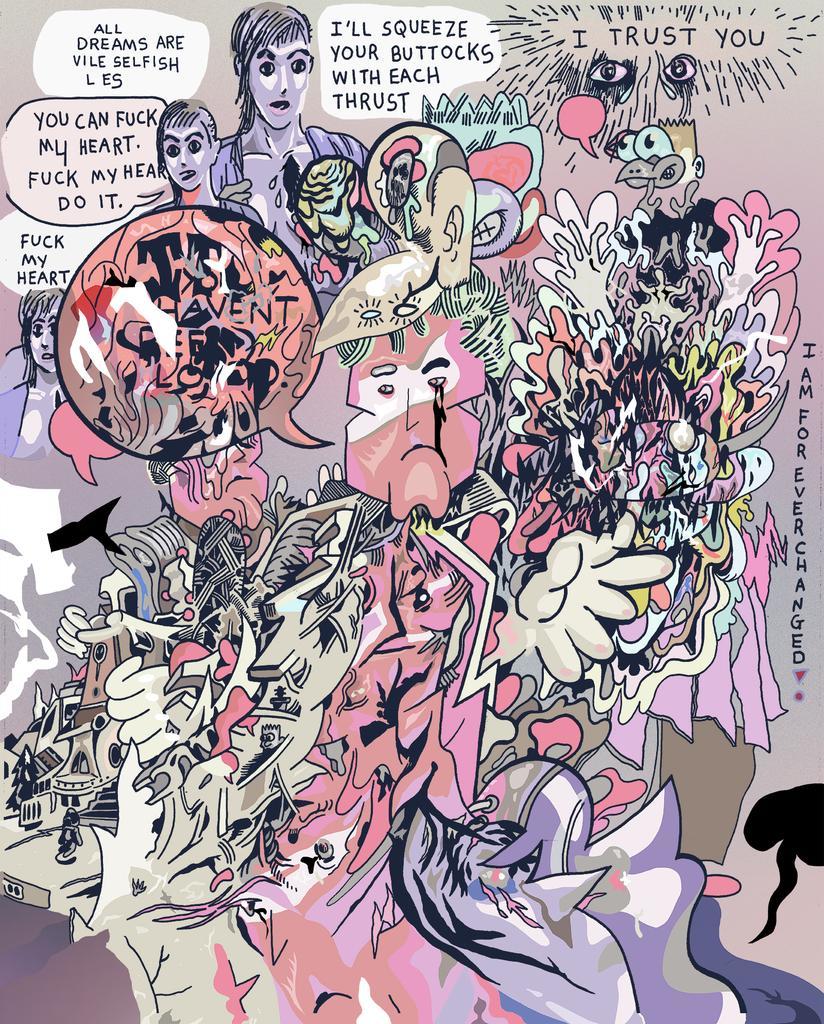Can you describe this image briefly? This is a cartoon image. 